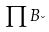Convert formula to latex. <formula><loc_0><loc_0><loc_500><loc_500>\prod B _ { \lambda }</formula> 